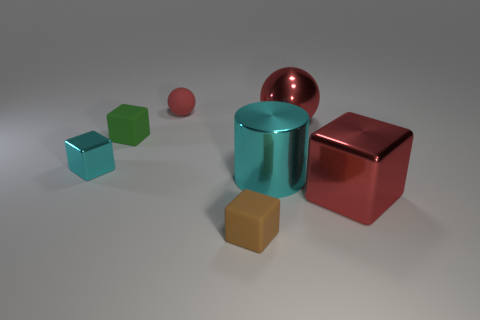Subtract 1 blocks. How many blocks are left? 3 Subtract all green cubes. How many cubes are left? 3 Add 2 large red shiny spheres. How many objects exist? 9 Subtract all big red blocks. How many blocks are left? 3 Subtract all gray cubes. Subtract all brown balls. How many cubes are left? 4 Subtract all cylinders. How many objects are left? 6 Add 2 tiny shiny things. How many tiny shiny things exist? 3 Subtract 0 blue spheres. How many objects are left? 7 Subtract all red things. Subtract all brown rubber balls. How many objects are left? 4 Add 1 green rubber blocks. How many green rubber blocks are left? 2 